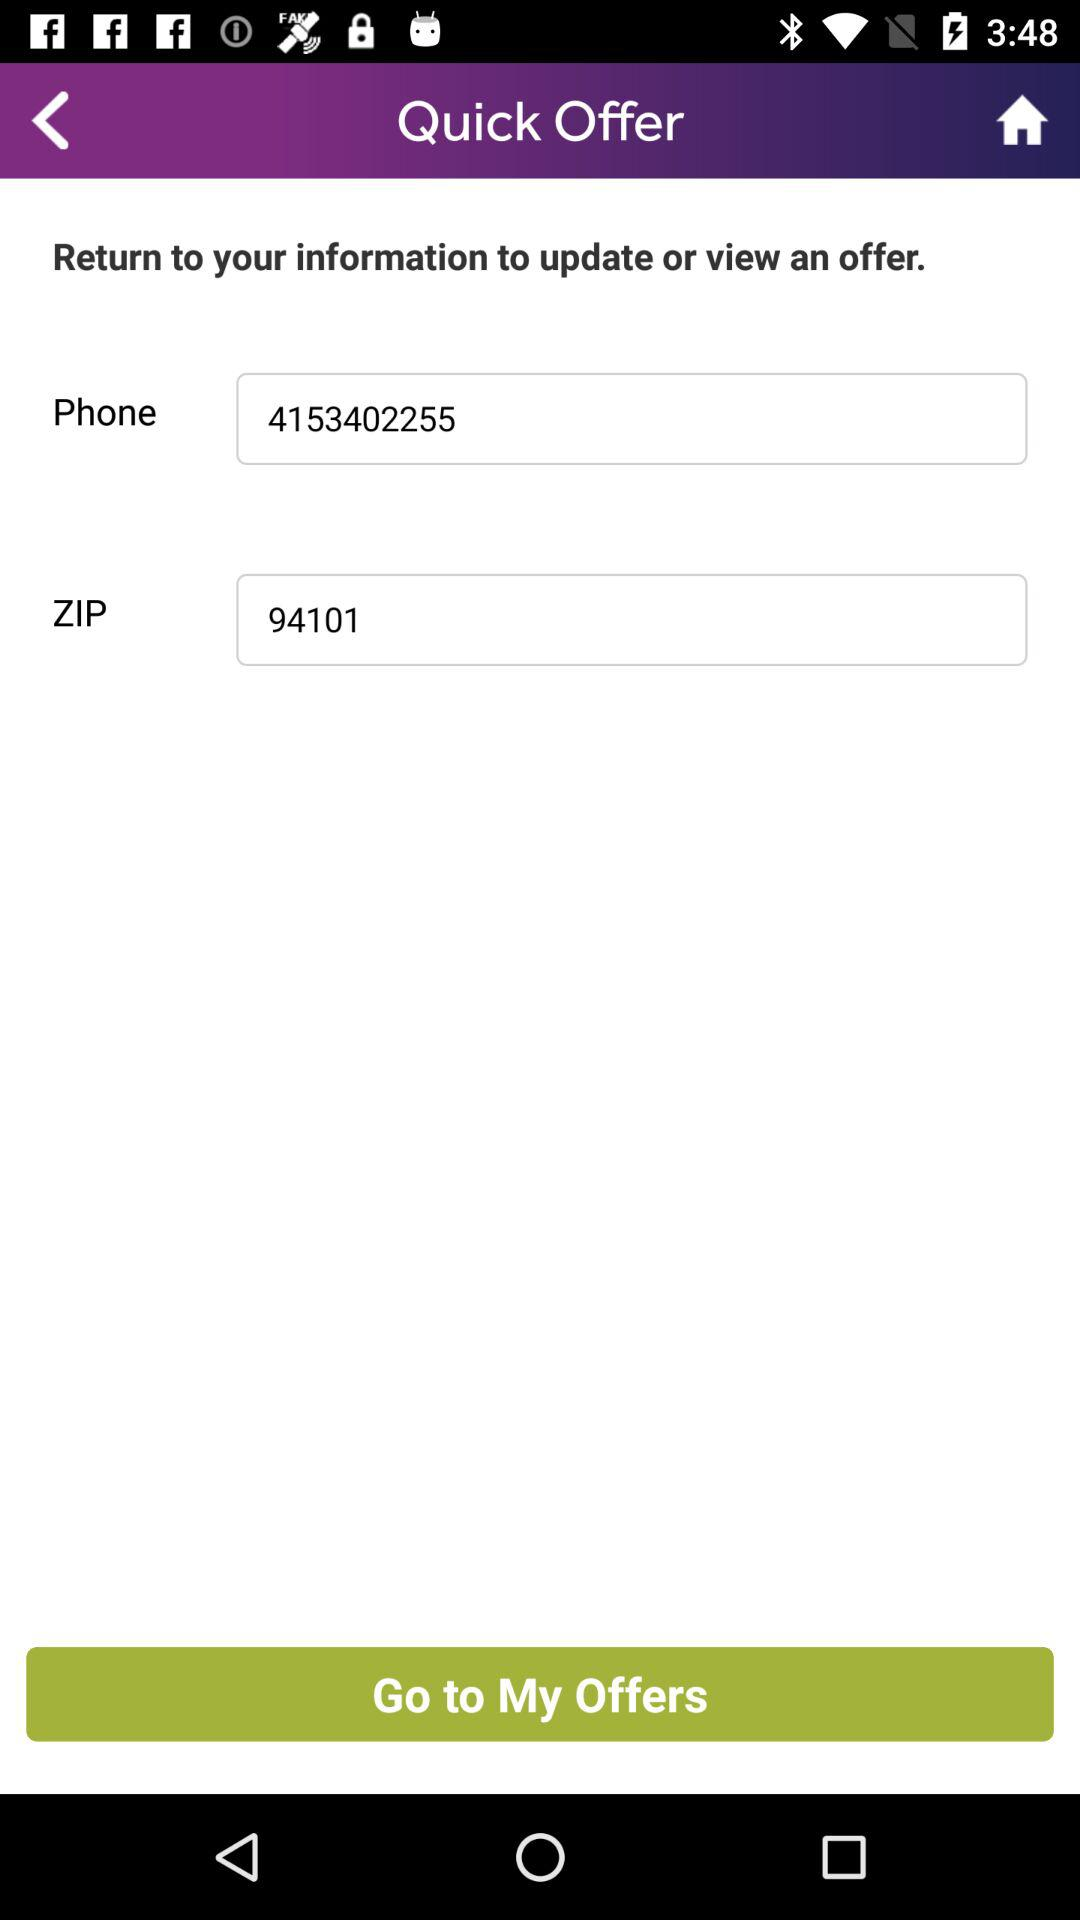What is the phone number? The phone number is 4153402255. 